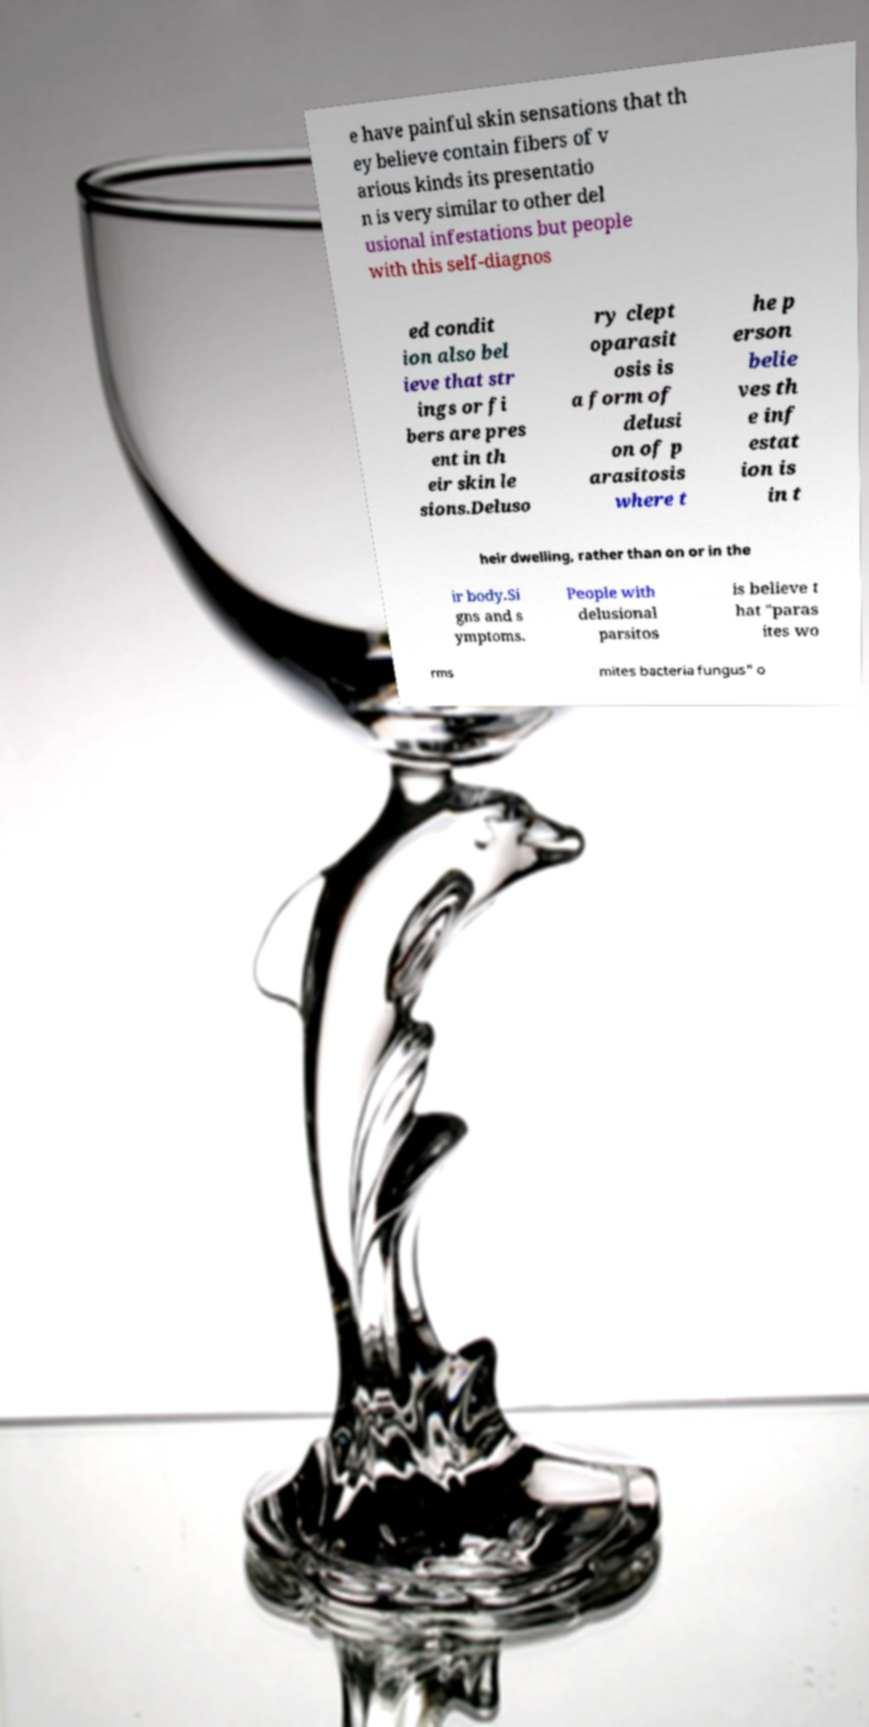Can you read and provide the text displayed in the image?This photo seems to have some interesting text. Can you extract and type it out for me? e have painful skin sensations that th ey believe contain fibers of v arious kinds its presentatio n is very similar to other del usional infestations but people with this self-diagnos ed condit ion also bel ieve that str ings or fi bers are pres ent in th eir skin le sions.Deluso ry clept oparasit osis is a form of delusi on of p arasitosis where t he p erson belie ves th e inf estat ion is in t heir dwelling, rather than on or in the ir body.Si gns and s ymptoms. People with delusional parsitos is believe t hat "paras ites wo rms mites bacteria fungus" o 